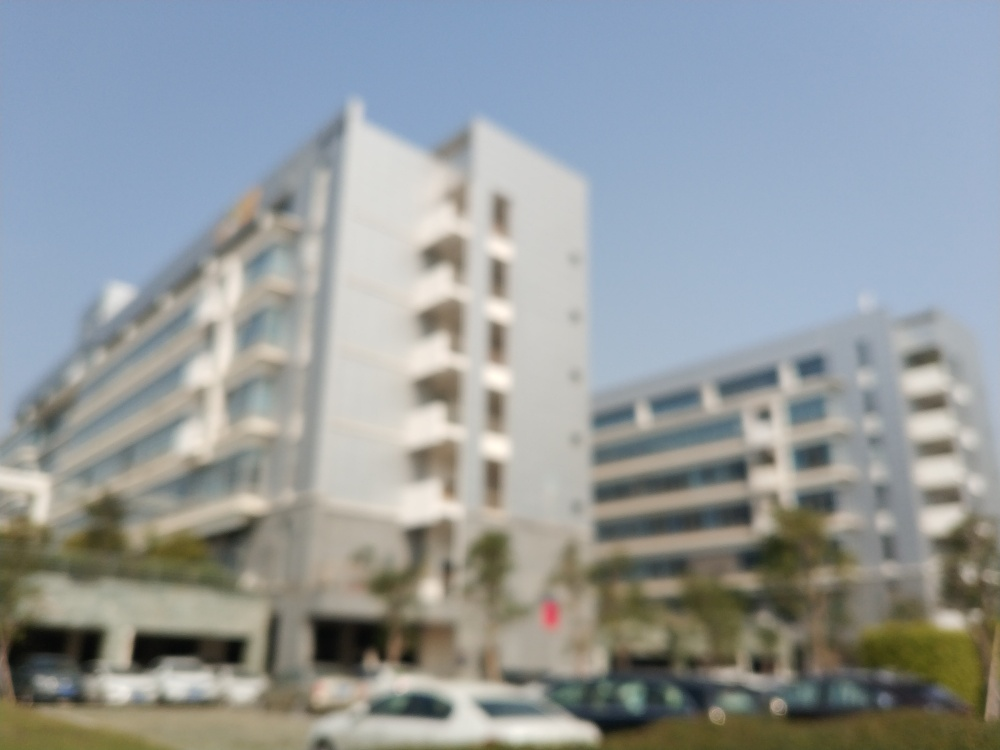Is the image well-lit? The image appears to be taken in daylight with no harsh shadows, suggesting it is indeed well-lit; however, the image is not clear due to it being out of focus, which affects the perception of lighting. 